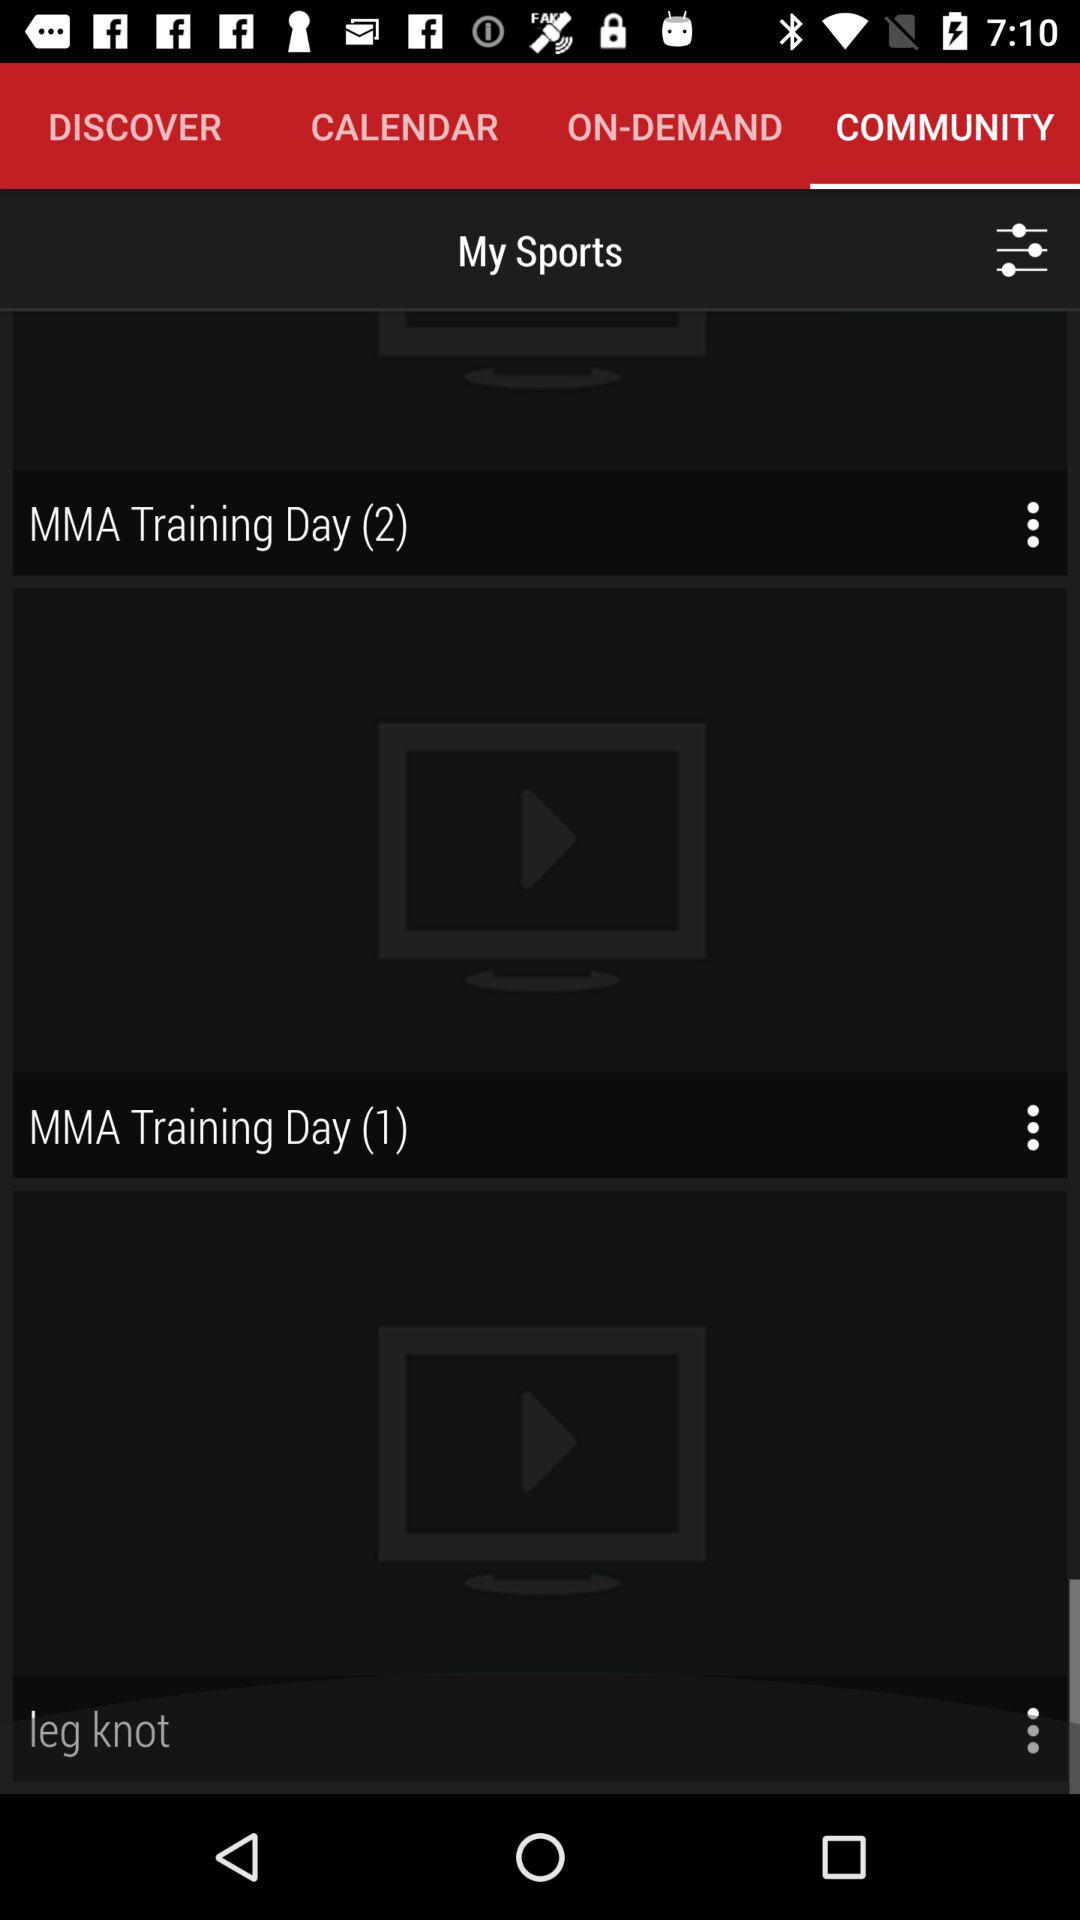How many more MMA Training Day videos are there than leg knot videos?
Answer the question using a single word or phrase. 1 